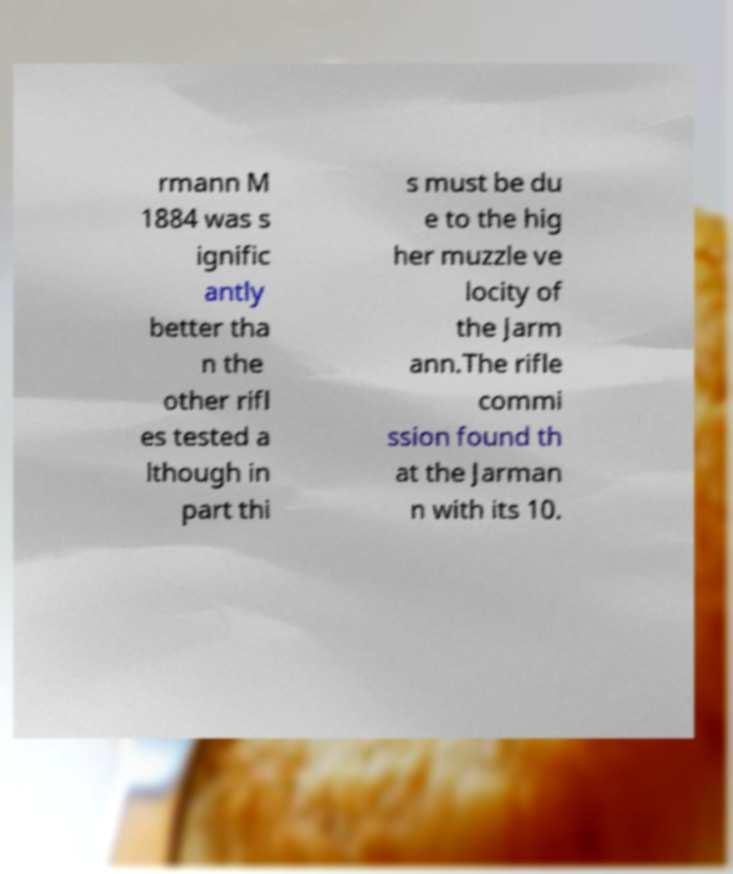Can you read and provide the text displayed in the image?This photo seems to have some interesting text. Can you extract and type it out for me? rmann M 1884 was s ignific antly better tha n the other rifl es tested a lthough in part thi s must be du e to the hig her muzzle ve locity of the Jarm ann.The rifle commi ssion found th at the Jarman n with its 10. 